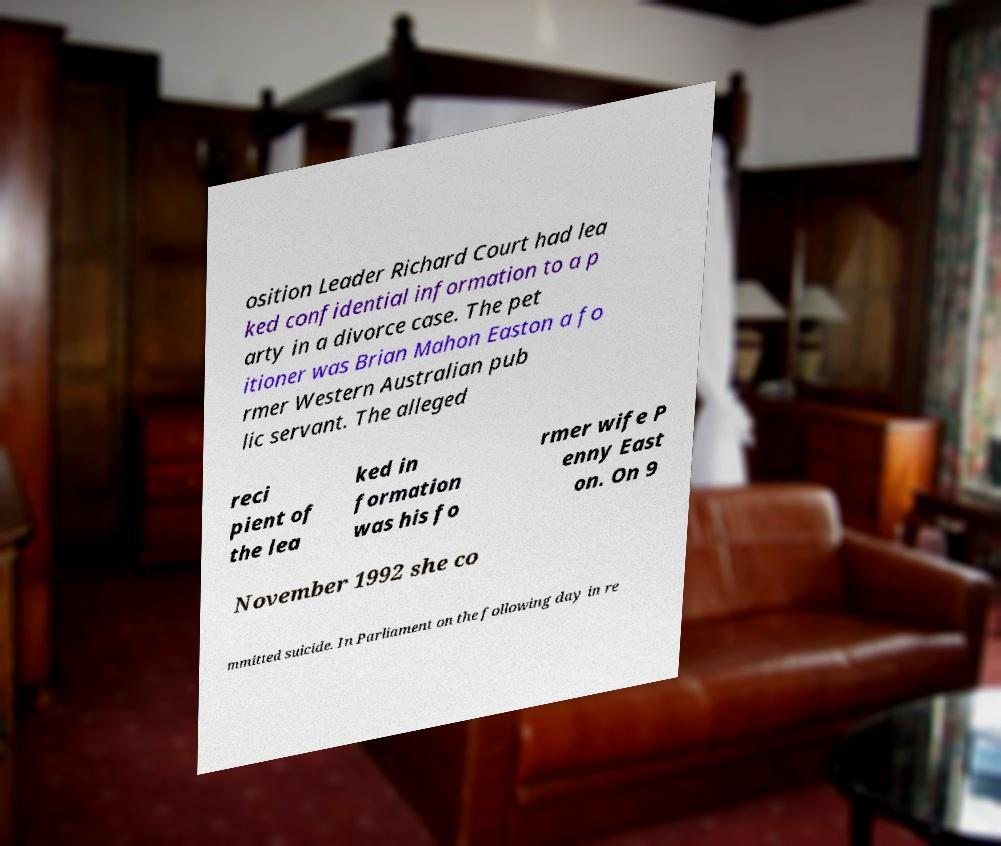What messages or text are displayed in this image? I need them in a readable, typed format. osition Leader Richard Court had lea ked confidential information to a p arty in a divorce case. The pet itioner was Brian Mahon Easton a fo rmer Western Australian pub lic servant. The alleged reci pient of the lea ked in formation was his fo rmer wife P enny East on. On 9 November 1992 she co mmitted suicide. In Parliament on the following day in re 